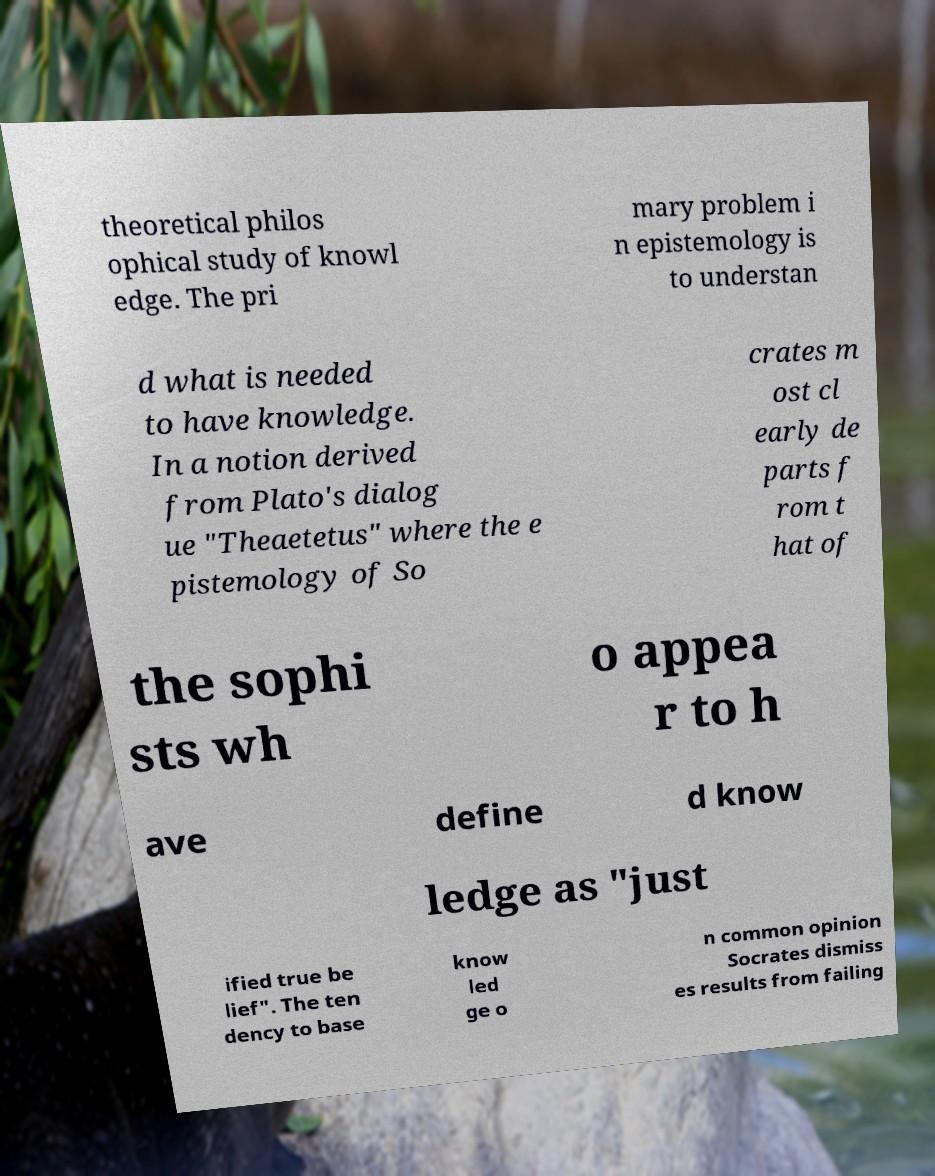Can you accurately transcribe the text from the provided image for me? theoretical philos ophical study of knowl edge. The pri mary problem i n epistemology is to understan d what is needed to have knowledge. In a notion derived from Plato's dialog ue "Theaetetus" where the e pistemology of So crates m ost cl early de parts f rom t hat of the sophi sts wh o appea r to h ave define d know ledge as "just ified true be lief". The ten dency to base know led ge o n common opinion Socrates dismiss es results from failing 